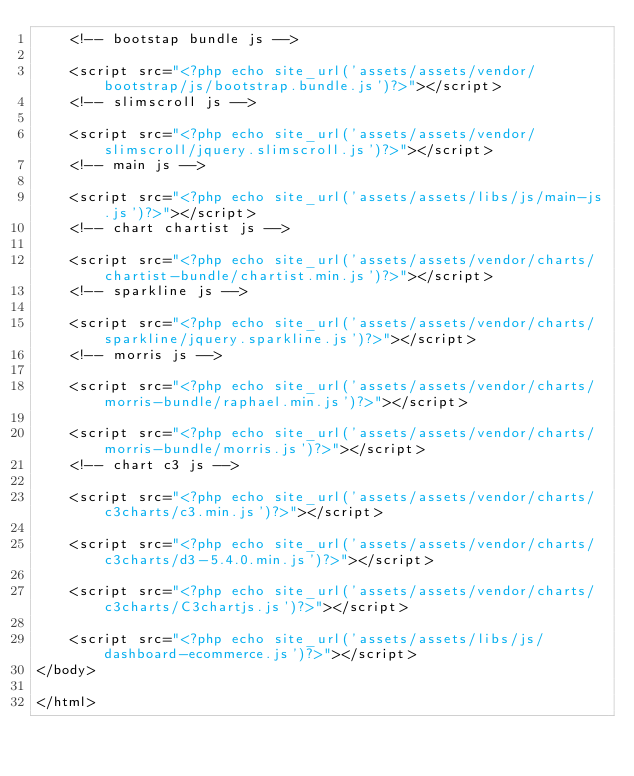Convert code to text. <code><loc_0><loc_0><loc_500><loc_500><_PHP_>    <!-- bootstap bundle js -->

    <script src="<?php echo site_url('assets/assets/vendor/bootstrap/js/bootstrap.bundle.js')?>"></script>
    <!-- slimscroll js -->

    <script src="<?php echo site_url('assets/assets/vendor/slimscroll/jquery.slimscroll.js')?>"></script>
    <!-- main js -->

    <script src="<?php echo site_url('assets/assets/libs/js/main-js.js')?>"></script>
    <!-- chart chartist js -->

    <script src="<?php echo site_url('assets/assets/vendor/charts/chartist-bundle/chartist.min.js')?>"></script>
    <!-- sparkline js -->

    <script src="<?php echo site_url('assets/assets/vendor/charts/sparkline/jquery.sparkline.js')?>"></script>
    <!-- morris js -->

    <script src="<?php echo site_url('assets/assets/vendor/charts/morris-bundle/raphael.min.js')?>"></script>

    <script src="<?php echo site_url('assets/assets/vendor/charts/morris-bundle/morris.js')?>"></script>
    <!-- chart c3 js -->

    <script src="<?php echo site_url('assets/assets/vendor/charts/c3charts/c3.min.js')?>"></script>

    <script src="<?php echo site_url('assets/assets/vendor/charts/c3charts/d3-5.4.0.min.js')?>"></script>

    <script src="<?php echo site_url('assets/assets/vendor/charts/c3charts/C3chartjs.js')?>"></script>

    <script src="<?php echo site_url('assets/assets/libs/js/dashboard-ecommerce.js')?>"></script>
</body>
 
</html></code> 